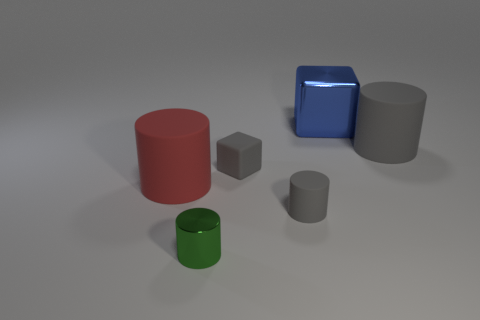How many large objects are either green metal objects or red matte spheres?
Provide a succinct answer. 0. There is a gray matte cylinder that is left of the large gray matte cylinder; are there any gray objects behind it?
Your answer should be very brief. Yes. Is there a tiny green thing?
Give a very brief answer. Yes. What is the color of the large thing that is on the right side of the metallic cube that is behind the small green shiny cylinder?
Offer a terse response. Gray. There is another large object that is the same shape as the large red thing; what is it made of?
Offer a terse response. Rubber. What number of red metal things are the same size as the green metallic thing?
Offer a very short reply. 0. There is a blue thing that is the same material as the small green object; what is its size?
Make the answer very short. Large. How many green objects have the same shape as the large blue object?
Your answer should be compact. 0. How many big green metal cubes are there?
Offer a terse response. 0. Is the shape of the metallic thing that is in front of the large block the same as  the large red thing?
Offer a very short reply. Yes. 